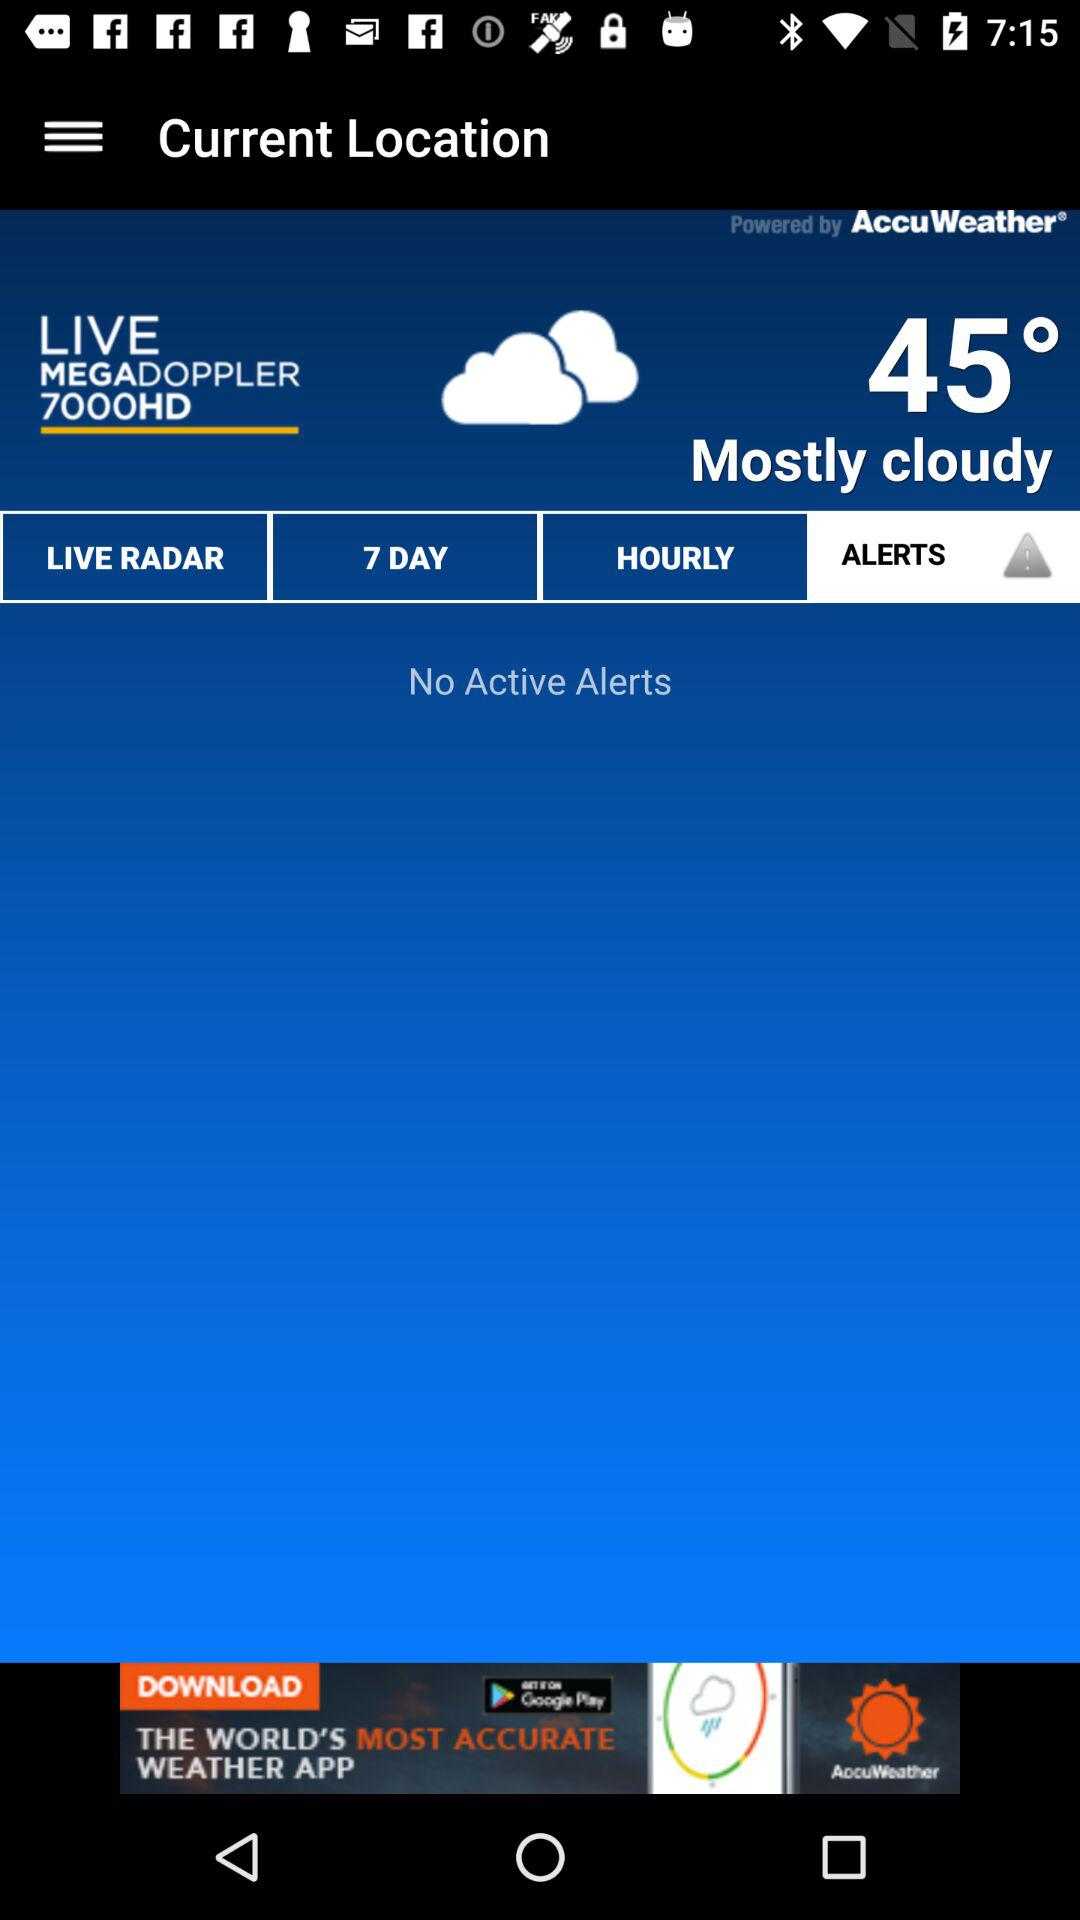What is the temperature?
Answer the question using a single word or phrase. 45° 